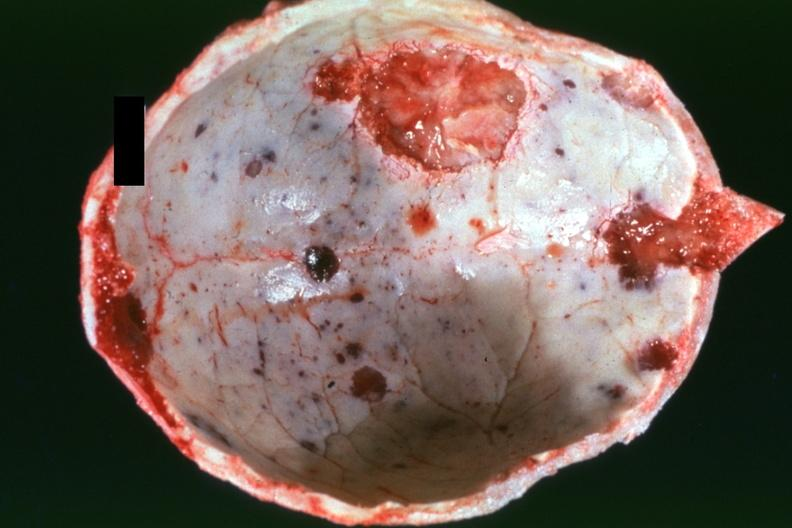s outside adrenal capsule section present?
Answer the question using a single word or phrase. No 